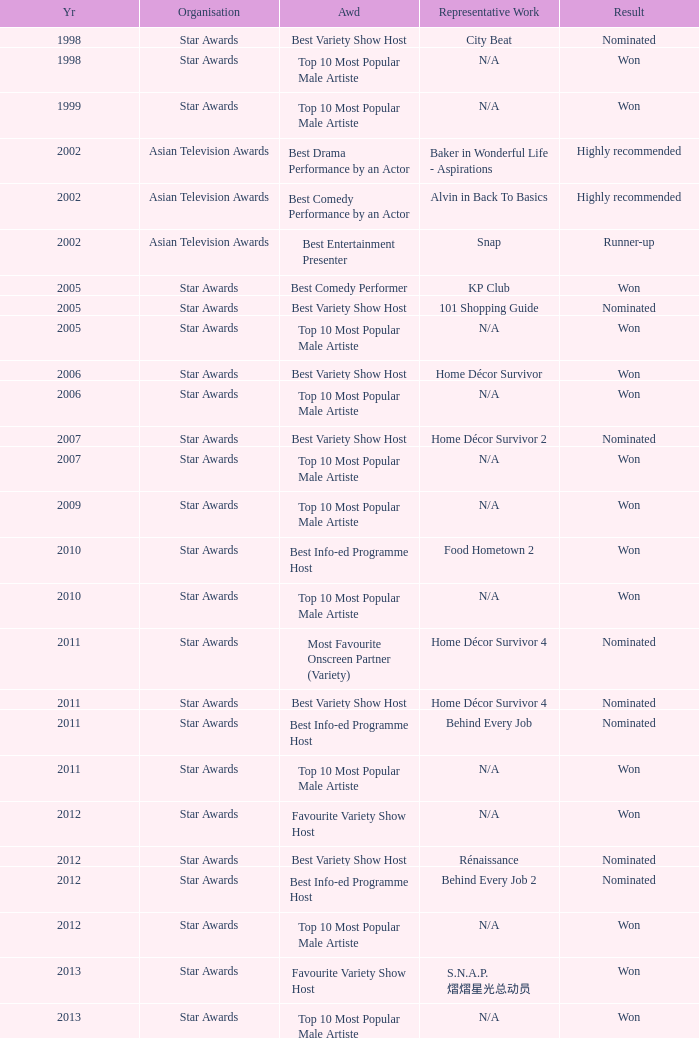What is the organisation in 2011 that was nominated and the award of best info-ed programme host? Star Awards. 